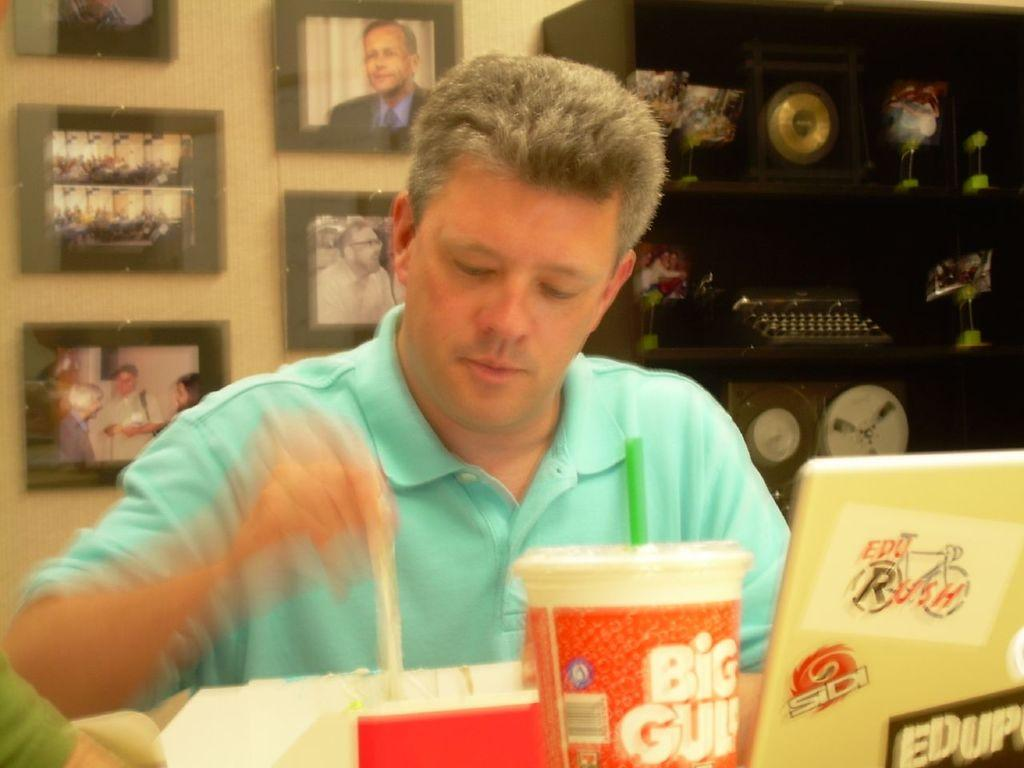<image>
Present a compact description of the photo's key features. Man getting ready to eat some food next to a cup saying BIG GULP. 